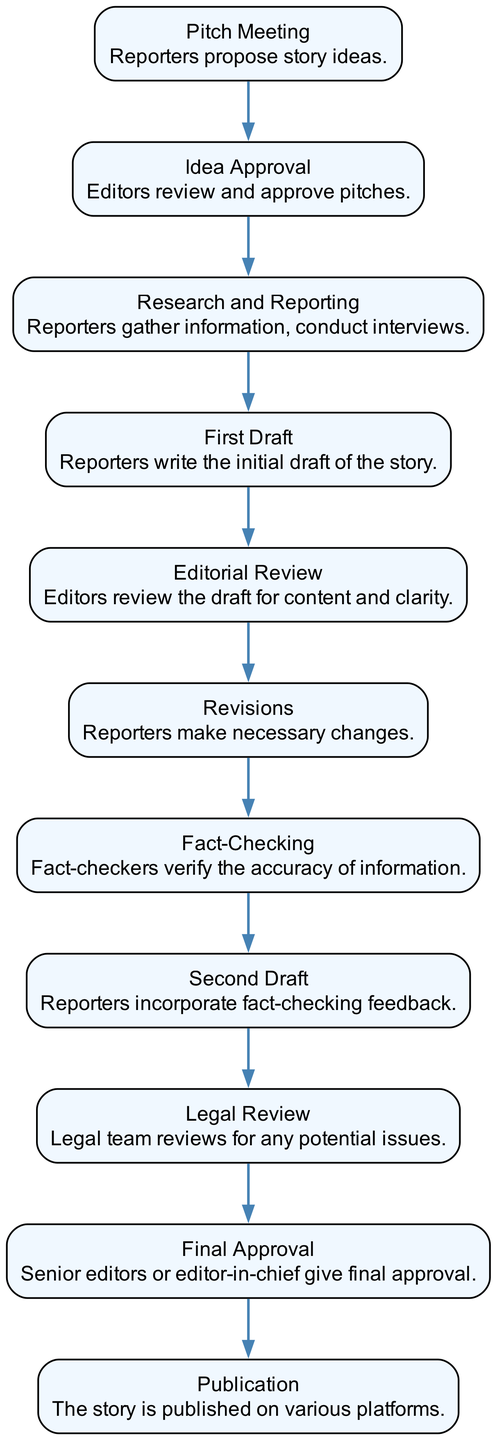What is the first step in the workflow process? The first step is the "Pitch Meeting," where reporters propose story ideas.
Answer: Pitch Meeting How many steps are there in the workflow process? By counting all the distinct steps from pitch to publication, there are 11 steps in total.
Answer: 11 What happens after the "First Draft"? After the "First Draft," the process moves to "Editorial Review," where editors review the draft for content and clarity.
Answer: Editorial Review Which step involves verifying the accuracy of information? The "Fact-Checking" step involves verifying the accuracy of the information presented in the draft.
Answer: Fact-Checking Who gives the final approval before publication? The "Senior editors" or "editor-in-chief" give the final approval before the story is published.
Answer: Senior editors or editor-in-chief What is the step that follows "Revisions"? According to the workflow, the step that follows "Revisions" is "Fact-Checking," where fact-checkers verify the accuracy of the revised draft.
Answer: Fact-Checking How many approval stages are there in the workflow? There are two distinct approval stages in the workflow: "Idea Approval" and "Final Approval."
Answer: Two What is the last step in the story creation process? The last step in the workflow process is "Publication," where the story is published on various platforms.
Answer: Publication Which step comes after "Research and Reporting"? Following "Research and Reporting," the next step is "First Draft," where reporters write the initial draft of the story.
Answer: First Draft 